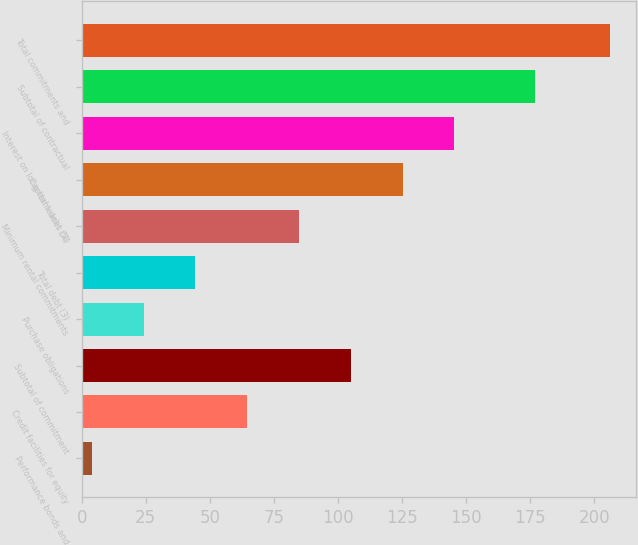<chart> <loc_0><loc_0><loc_500><loc_500><bar_chart><fcel>Performance bonds and<fcel>Credit facilities for equity<fcel>Subtotal of commitment<fcel>Purchase obligations<fcel>Total debt (3)<fcel>Minimum rental commitments<fcel>Capital leases (4)<fcel>Interest on long-term debt (5)<fcel>Subtotal of contractual<fcel>Total commitments and<nl><fcel>4<fcel>64.6<fcel>105<fcel>24.2<fcel>44.4<fcel>84.8<fcel>125.2<fcel>145.4<fcel>177<fcel>206<nl></chart> 